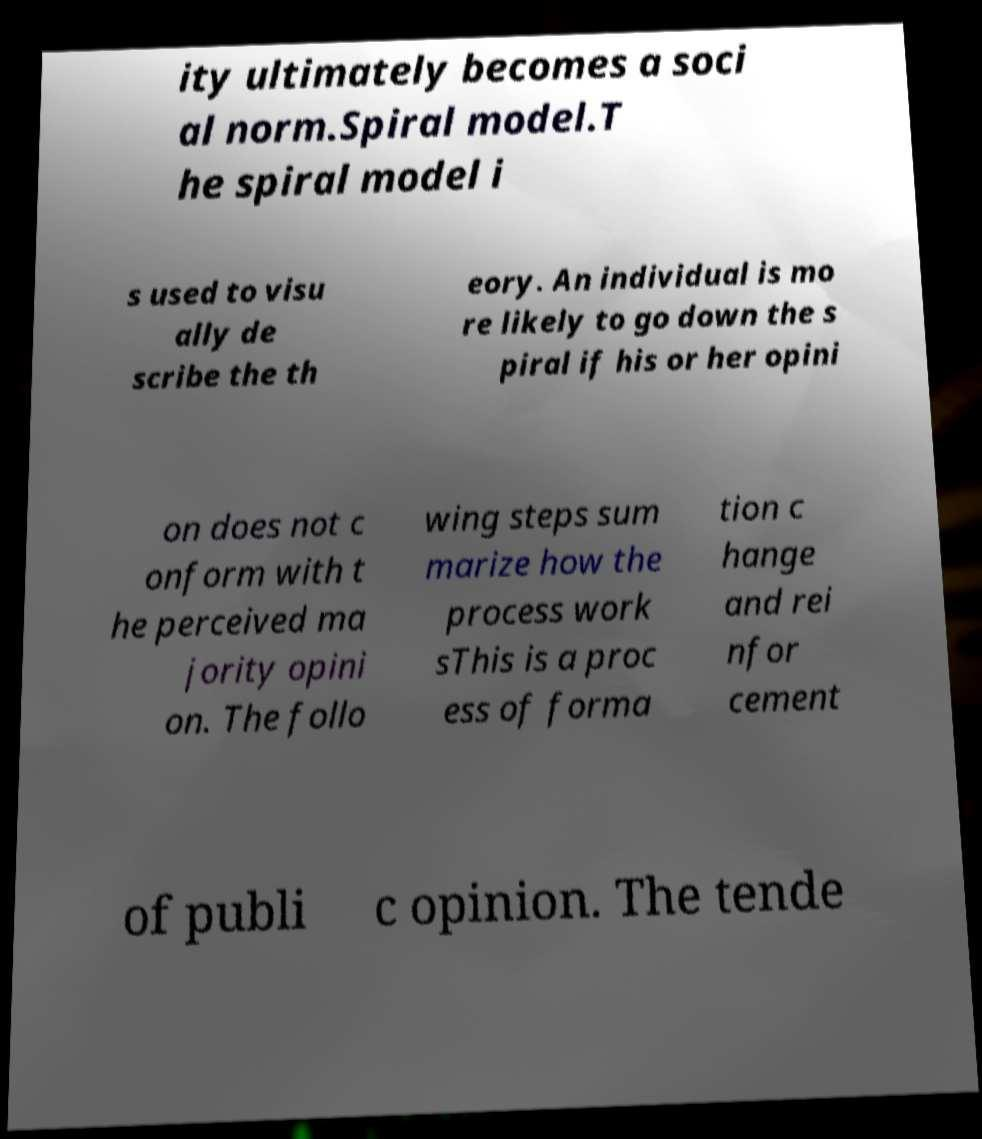Could you extract and type out the text from this image? ity ultimately becomes a soci al norm.Spiral model.T he spiral model i s used to visu ally de scribe the th eory. An individual is mo re likely to go down the s piral if his or her opini on does not c onform with t he perceived ma jority opini on. The follo wing steps sum marize how the process work sThis is a proc ess of forma tion c hange and rei nfor cement of publi c opinion. The tende 